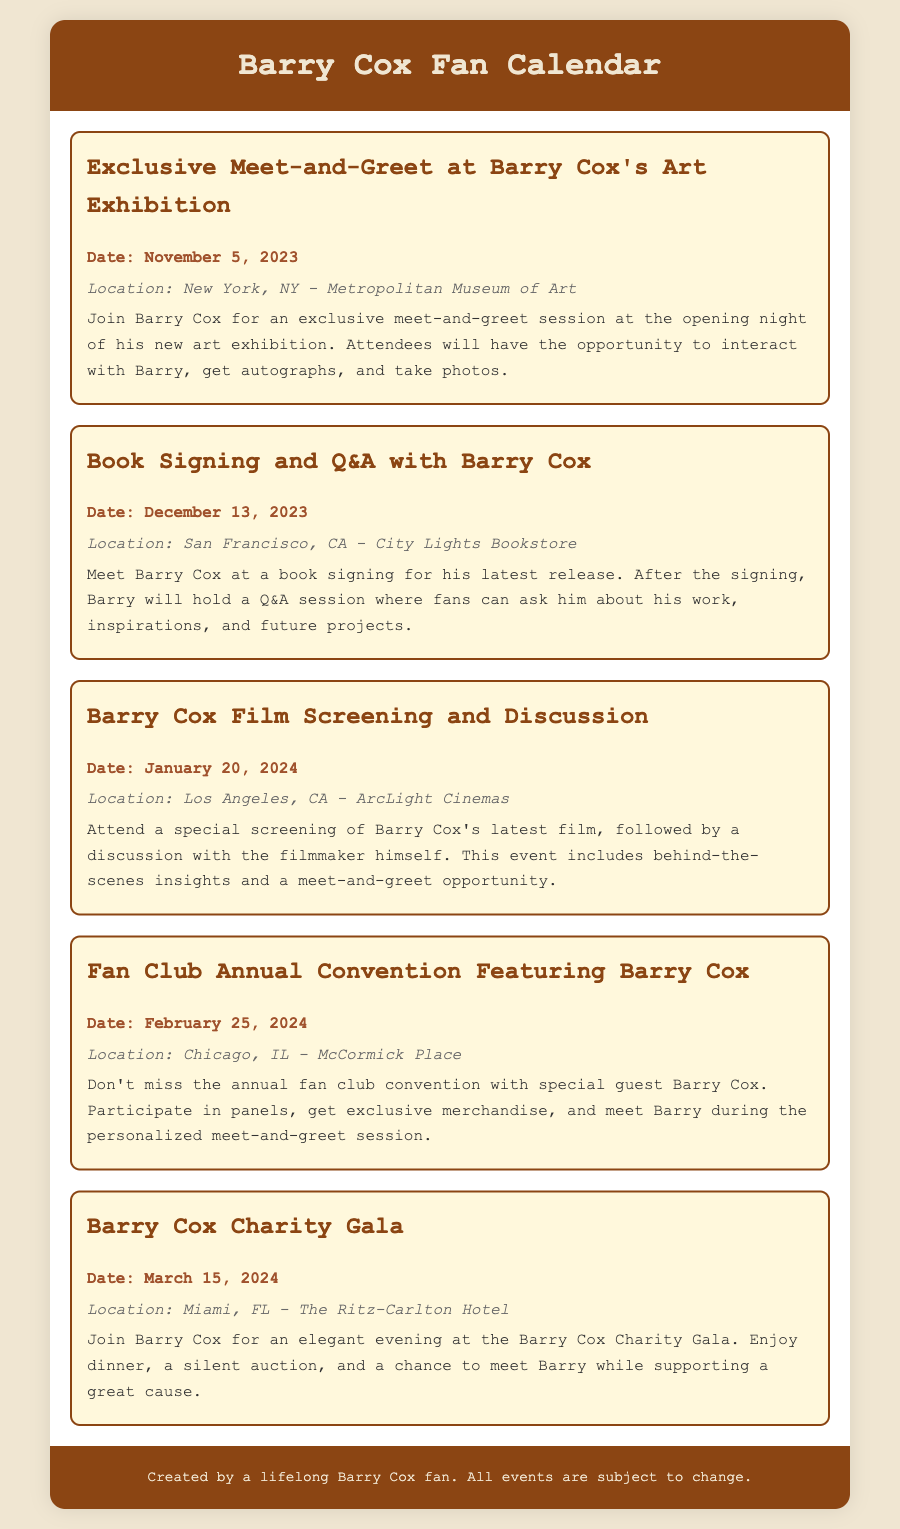What is the date of the exclusive meet-and-greet? The date is specified in the document for the exclusive meet-and-greet event with Barry Cox.
Answer: November 5, 2023 Where will the book signing take place? The document lists the location for the book signing and Q&A event with Barry Cox.
Answer: San Francisco, CA - City Lights Bookstore What type of event is on January 20, 2024? The event type is described in the document for January 20, which includes a film screening and discussion.
Answer: Film Screening and Discussion What is the location of the charity gala? The document provides the location where the Barry Cox Charity Gala is being held.
Answer: Miami, FL - The Ritz-Carlton Hotel How many events are listed in the calendar? Counting the events from the document reveals the total number of listed events.
Answer: Five 